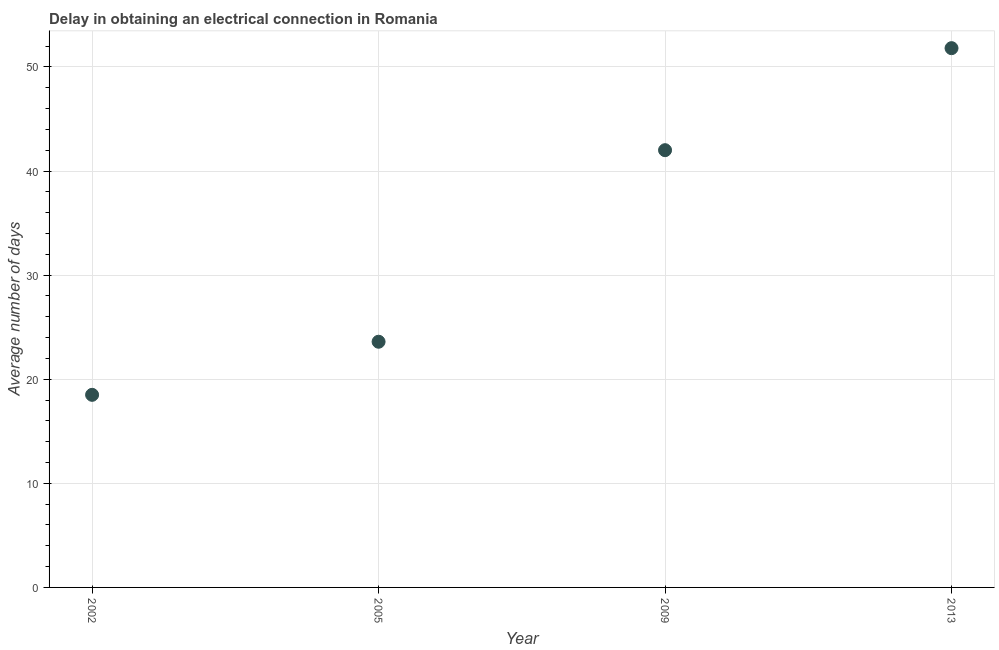What is the dalay in electrical connection in 2013?
Give a very brief answer. 51.8. Across all years, what is the maximum dalay in electrical connection?
Offer a terse response. 51.8. Across all years, what is the minimum dalay in electrical connection?
Provide a short and direct response. 18.5. In which year was the dalay in electrical connection maximum?
Offer a very short reply. 2013. What is the sum of the dalay in electrical connection?
Keep it short and to the point. 135.9. What is the difference between the dalay in electrical connection in 2005 and 2009?
Offer a terse response. -18.4. What is the average dalay in electrical connection per year?
Keep it short and to the point. 33.97. What is the median dalay in electrical connection?
Make the answer very short. 32.8. In how many years, is the dalay in electrical connection greater than 16 days?
Provide a succinct answer. 4. What is the ratio of the dalay in electrical connection in 2005 to that in 2013?
Keep it short and to the point. 0.46. Is the dalay in electrical connection in 2009 less than that in 2013?
Provide a short and direct response. Yes. Is the difference between the dalay in electrical connection in 2002 and 2009 greater than the difference between any two years?
Offer a terse response. No. What is the difference between the highest and the second highest dalay in electrical connection?
Make the answer very short. 9.8. Is the sum of the dalay in electrical connection in 2009 and 2013 greater than the maximum dalay in electrical connection across all years?
Your response must be concise. Yes. What is the difference between the highest and the lowest dalay in electrical connection?
Keep it short and to the point. 33.3. Does the dalay in electrical connection monotonically increase over the years?
Offer a very short reply. Yes. How many years are there in the graph?
Keep it short and to the point. 4. What is the difference between two consecutive major ticks on the Y-axis?
Provide a succinct answer. 10. What is the title of the graph?
Your response must be concise. Delay in obtaining an electrical connection in Romania. What is the label or title of the X-axis?
Your response must be concise. Year. What is the label or title of the Y-axis?
Your response must be concise. Average number of days. What is the Average number of days in 2002?
Give a very brief answer. 18.5. What is the Average number of days in 2005?
Your answer should be very brief. 23.6. What is the Average number of days in 2013?
Provide a short and direct response. 51.8. What is the difference between the Average number of days in 2002 and 2005?
Your answer should be very brief. -5.1. What is the difference between the Average number of days in 2002 and 2009?
Your answer should be very brief. -23.5. What is the difference between the Average number of days in 2002 and 2013?
Offer a terse response. -33.3. What is the difference between the Average number of days in 2005 and 2009?
Provide a short and direct response. -18.4. What is the difference between the Average number of days in 2005 and 2013?
Make the answer very short. -28.2. What is the ratio of the Average number of days in 2002 to that in 2005?
Ensure brevity in your answer.  0.78. What is the ratio of the Average number of days in 2002 to that in 2009?
Your answer should be very brief. 0.44. What is the ratio of the Average number of days in 2002 to that in 2013?
Make the answer very short. 0.36. What is the ratio of the Average number of days in 2005 to that in 2009?
Offer a very short reply. 0.56. What is the ratio of the Average number of days in 2005 to that in 2013?
Offer a terse response. 0.46. What is the ratio of the Average number of days in 2009 to that in 2013?
Ensure brevity in your answer.  0.81. 